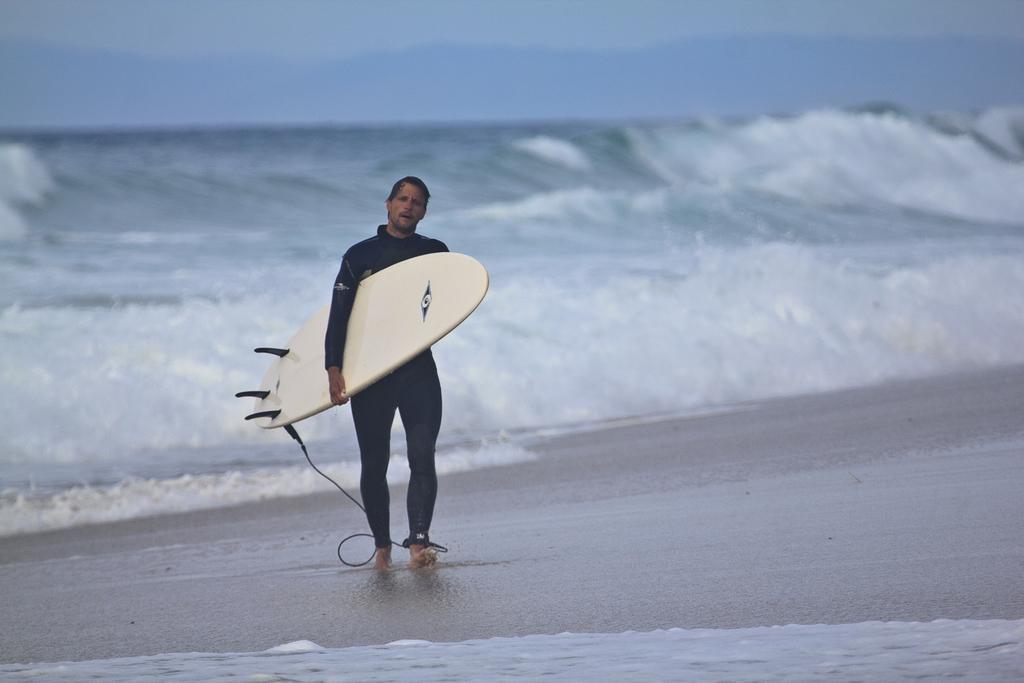In one or two sentences, can you explain what this image depicts? Front this person is walking and holding a surfboard. Backside of this person there is a fresh water river and we can able to see waves. 